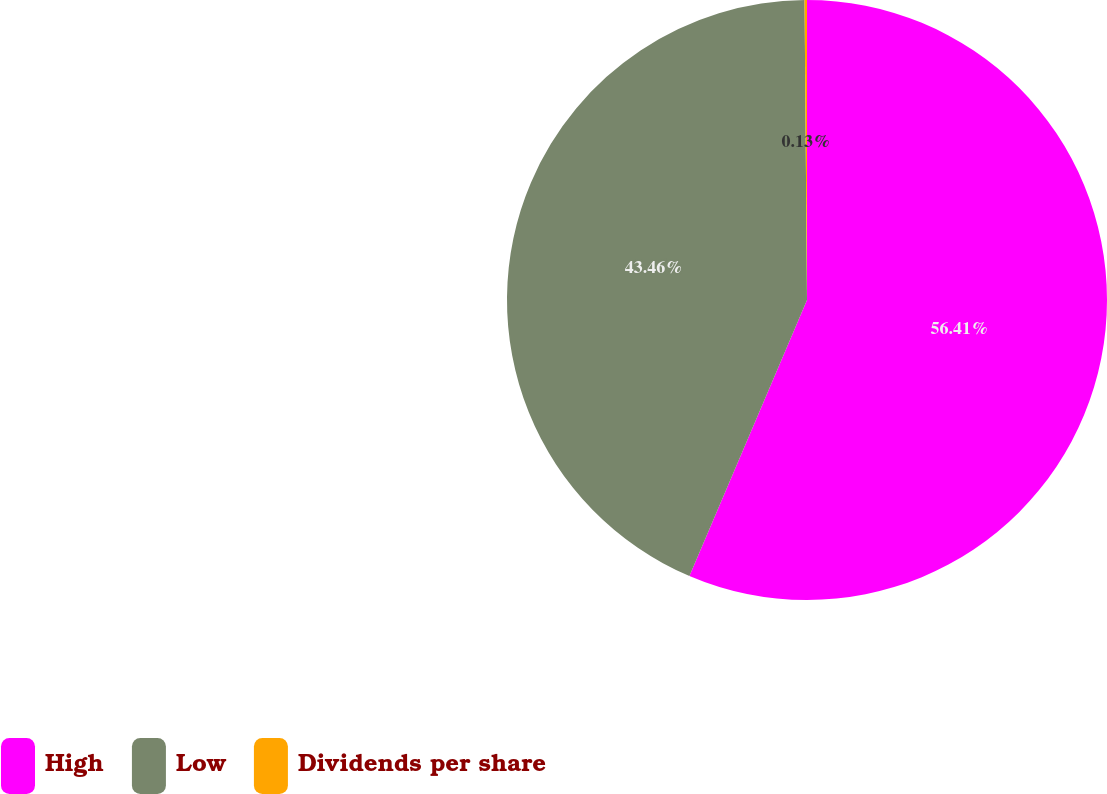<chart> <loc_0><loc_0><loc_500><loc_500><pie_chart><fcel>High<fcel>Low<fcel>Dividends per share<nl><fcel>56.41%<fcel>43.46%<fcel>0.13%<nl></chart> 